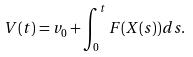<formula> <loc_0><loc_0><loc_500><loc_500>V ( t ) = v _ { 0 } + \int _ { 0 } ^ { t } F ( X ( s ) ) d s .</formula> 